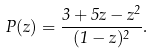Convert formula to latex. <formula><loc_0><loc_0><loc_500><loc_500>P ( z ) = \frac { 3 + 5 z - z ^ { 2 } } { ( 1 - z ) ^ { 2 } } .</formula> 